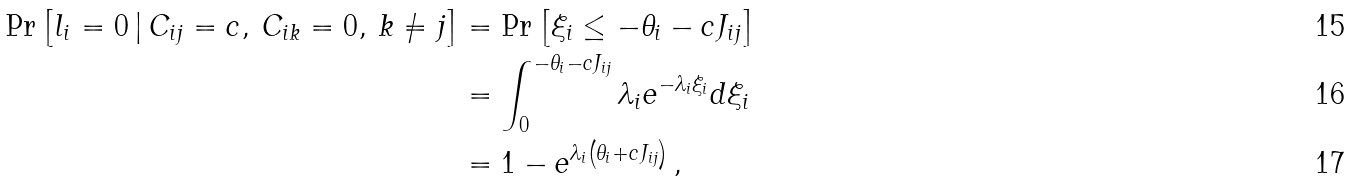Convert formula to latex. <formula><loc_0><loc_0><loc_500><loc_500>\Pr \left [ l _ { i } = 0 \, | \, C _ { i j } = c , \, C _ { i k } = 0 , \, k \neq j \right ] & = \Pr \left [ \xi _ { i } \leq - \theta _ { i } - c J _ { i j } \right ] \\ & = \int _ { 0 } ^ { - \theta _ { i } - c J _ { i j } } { \lambda _ { i } e ^ { - \lambda _ { i } \xi _ { i } } d \xi _ { i } } \\ & = 1 - e ^ { \lambda _ { i } \left ( \theta _ { i } + c J _ { i j } \right ) } \, ,</formula> 